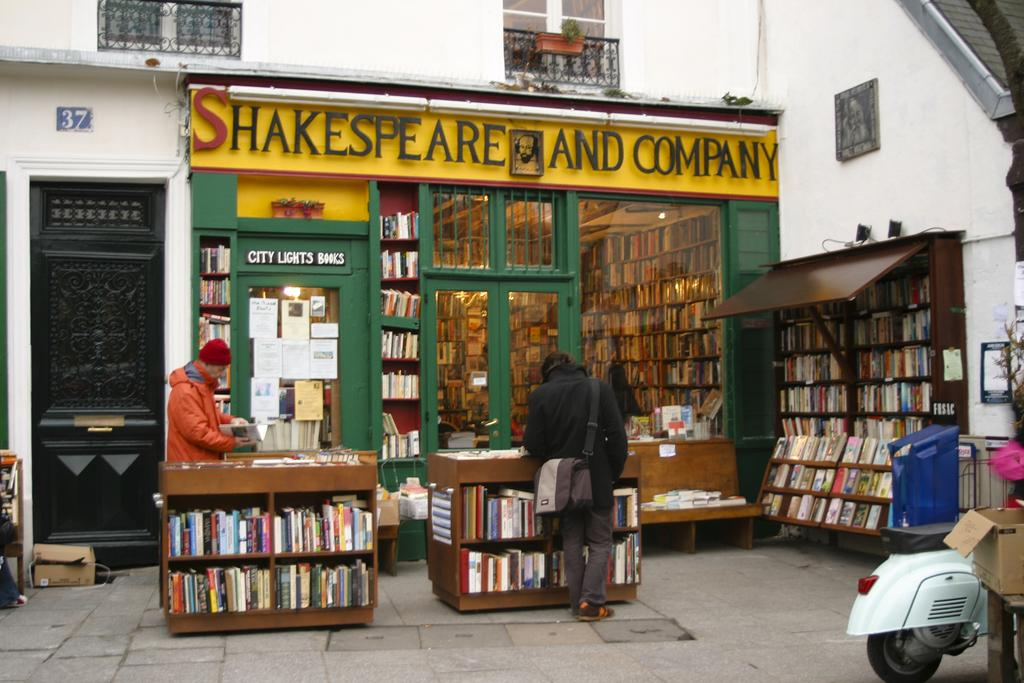Provide a one-sentence caption for the provided image. the front entrance to a book store named shakespeare and company. 